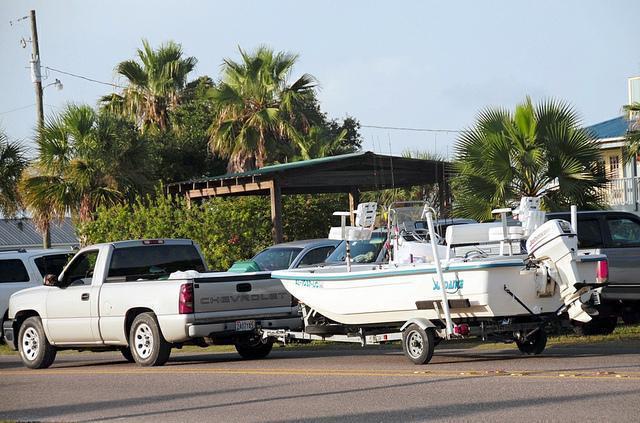What type of area is this?
Indicate the correct response by choosing from the four available options to answer the question.
Options: Tropical, urban, mountains, farm. Tropical. 